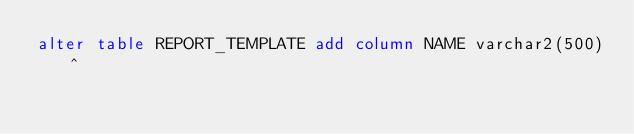Convert code to text. <code><loc_0><loc_0><loc_500><loc_500><_SQL_>alter table REPORT_TEMPLATE add column NAME varchar2(500)^

</code> 